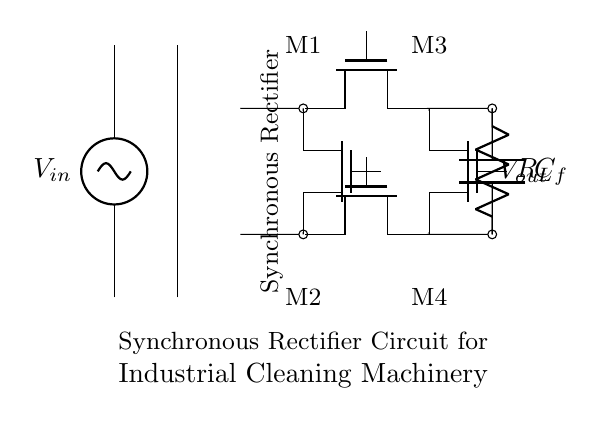What is the input voltage? The input voltage is indicated as V_in in the circuit diagram, which is the voltage supplied to the system.
Answer: V_in What are the types of components used? The circuit primarily uses Tnmos transistors, capacitors, and resistors, as identified by their symbols in the diagram.
Answer: Tnmos, C, R How many Tnmos transistors are present? There are four Tnmos transistors labeled M1, M2, M3, and M4 in the circuit diagram.
Answer: 4 What is the purpose of the capacitor in this circuit? The capacitor, labeled as C_f, is used to smooth the output voltage by filtering out fluctuations.
Answer: Smoothing output Why are synchronous rectifiers used in this circuit? Synchronous rectifiers improve energy efficiency by reducing the voltage drop and power loss compared to traditional diodes.
Answer: Energy efficiency What connects the Tnmos transistors in the bridge configuration? The Tnmos transistors are connected to each other in a manner that allows them to create a full-wave rectification circuit, effectively handling both halves of the AC input.
Answer: Bridge configuration What is the load resistor denoted as? The load resistor is labeled R_L in the circuit diagram, which represents the resistance that the output current will flow through.
Answer: R_L 